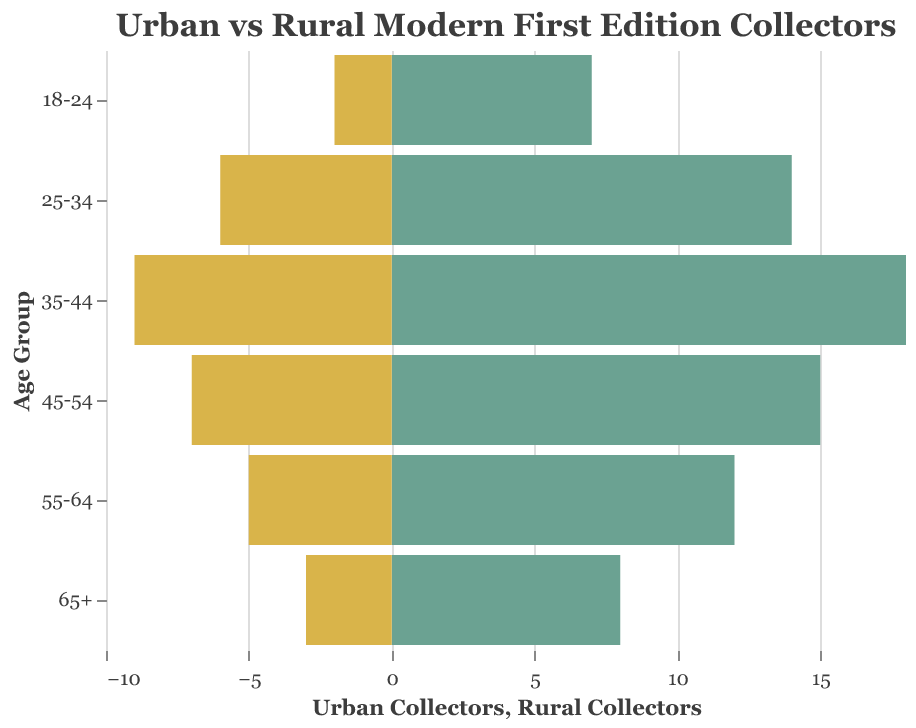How does the number of urban collectors compare to rural collectors in the 35-44 age group? Look at the bar lengths for the 35-44 age group. The urban collectors' bar represents 18 collectors, while the rural collectors' bar represents 9 collectors. Thus, urban collectors are twice as many as rural collectors in this age group.
Answer: Urban collectors are twice as many What is the title of the figure? The title is located at the top of the chart and provides a summary of what the data represents.
Answer: "Urban vs Rural Modern First Edition Collectors" Which age group has the largest number of rural collectors? Compare the lengths of the rural collectors' bars for all age groups. The longest bar represents the 35-44 age group with 9 rural collectors.
Answer: 35-44 What is the difference between the number of urban and rural collectors in the 25-34 age group? In the 25-34 age group, there are 14 urban collectors and 6 rural collectors. Subtract the number of rural collectors from the number of urban collectors (14 - 6).
Answer: 8 Across which age group is the difference between urban and rural collectors the smallest? Compare the numerical differences between urban and rural collectors across all age groups. The smallest difference is in the 18-24 age group (7 urban vs. 2 rural = 5).
Answer: 18-24 What color represents urban collectors? By examining the color coding in the figure legend or the bars themselves, urban collectors are shown in green (#6BA292).
Answer: Green How does the number of collectors aged 55-64 in urban areas compare to rural areas? Look at the bars for the 55-64 age group. The urban collectors' bar represents 12 collectors, while the rural collectors' bar represents 5 collectors. Urban collectors are more than double.
Answer: Urban collectors are more than double Which age group has the lowest number of urban collectors? Compare the bar lengths for urban collectors across all age groups. The shortest bar represents the 18-24 age group with 7 collectors.
Answer: 18-24 How many more urban collectors are there in the 45-54 age group than in the 65+ group? In the 45-54 age group, there are 15 urban collectors. In the 65+ group, there are 8. Subtract the number of 65+ urban collectors from the 45-54 urban collectors (15 - 8).
Answer: 7 